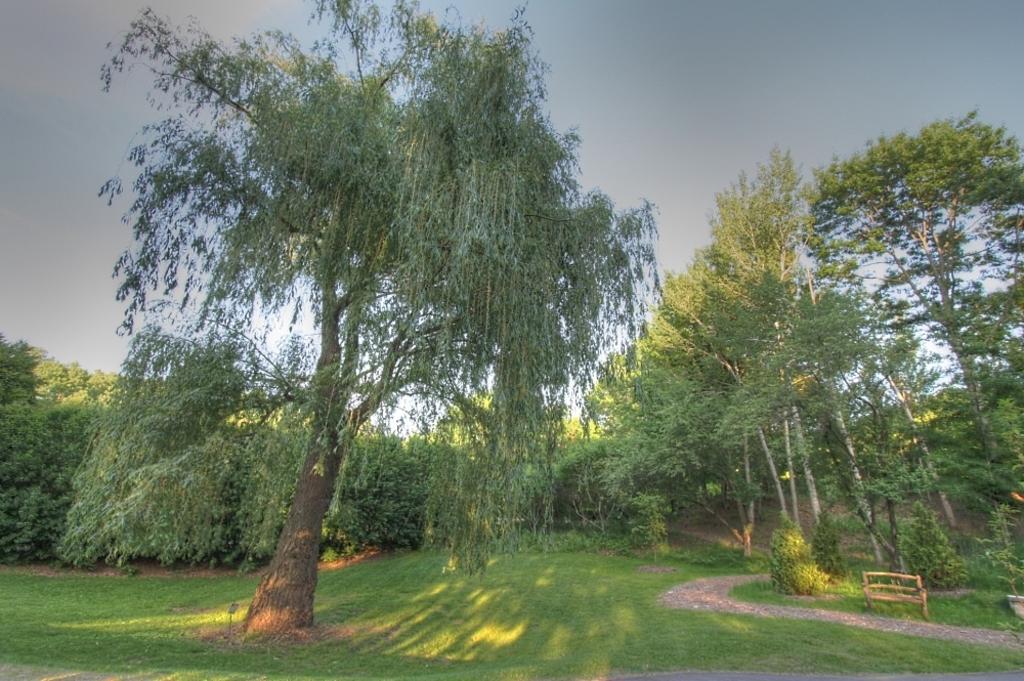Describe this image in one or two sentences. In this picture we can see grass, few trees and a bench. 